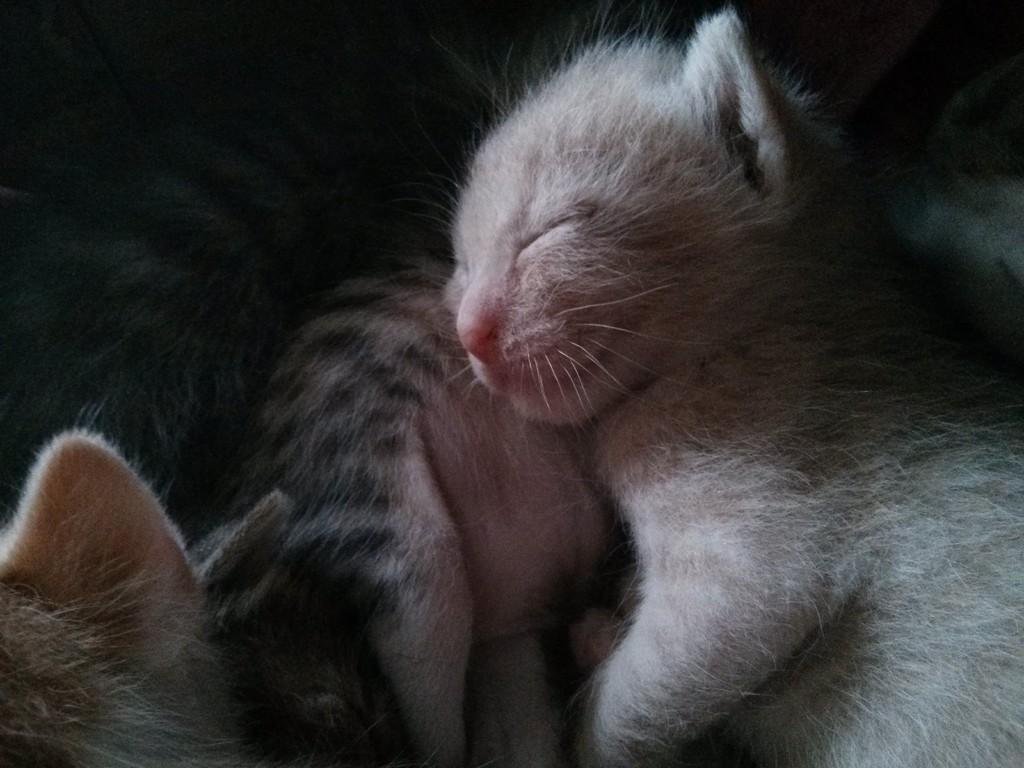Can you describe this image briefly? In the image there are cats sleeping. 